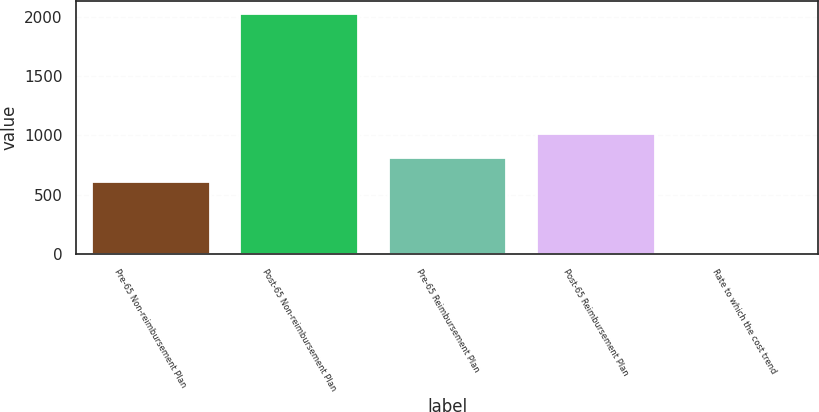Convert chart to OTSL. <chart><loc_0><loc_0><loc_500><loc_500><bar_chart><fcel>Pre-65 Non-reimbursement Plan<fcel>Post-65 Non-reimbursement Plan<fcel>Pre-65 Reimbursement Plan<fcel>Post-65 Reimbursement Plan<fcel>Rate to which the cost trend<nl><fcel>611.55<fcel>2028<fcel>813.9<fcel>1016.25<fcel>4.5<nl></chart> 